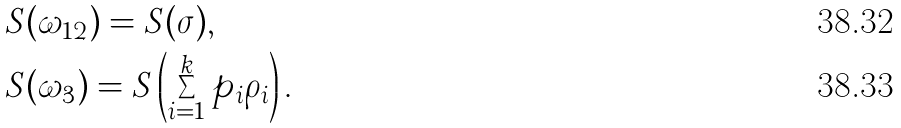Convert formula to latex. <formula><loc_0><loc_0><loc_500><loc_500>& S ( \omega _ { 1 2 } ) = S ( \sigma ) , \\ & S ( \omega _ { 3 } ) = S \left ( \sum _ { i = 1 } ^ { k } p _ { i } \rho _ { i } \right ) .</formula> 